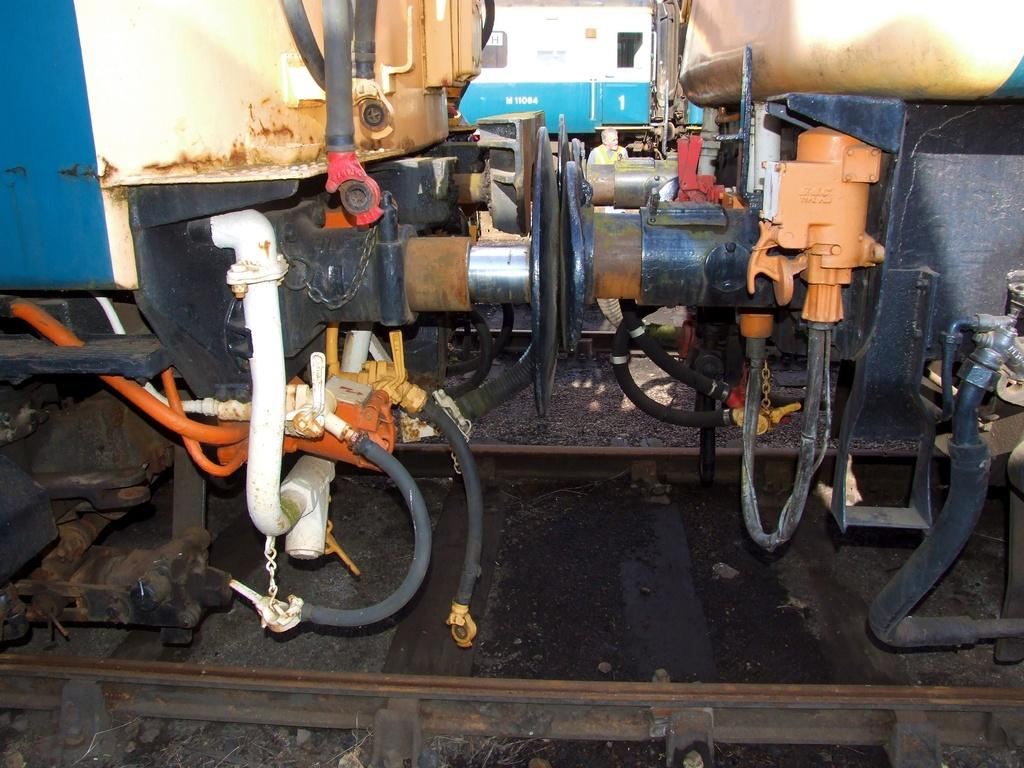What type of vehicles are in the image? There are trains in the image. Where are the trains located? The trains are on railway tracks. What can be observed about the appearance of the trains? The trains are in different colors. What letter is being written by the laborer in the image? There is no laborer or writing activity present in the image. 